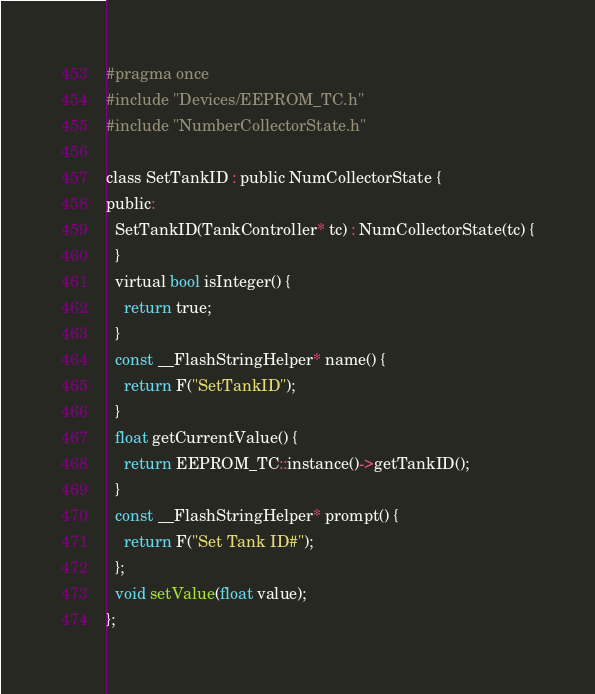<code> <loc_0><loc_0><loc_500><loc_500><_C_>#pragma once
#include "Devices/EEPROM_TC.h"
#include "NumberCollectorState.h"

class SetTankID : public NumCollectorState {
public:
  SetTankID(TankController* tc) : NumCollectorState(tc) {
  }
  virtual bool isInteger() {
    return true;
  }
  const __FlashStringHelper* name() {
    return F("SetTankID");
  }
  float getCurrentValue() {
    return EEPROM_TC::instance()->getTankID();
  }
  const __FlashStringHelper* prompt() {
    return F("Set Tank ID#");
  };
  void setValue(float value);
};
</code> 